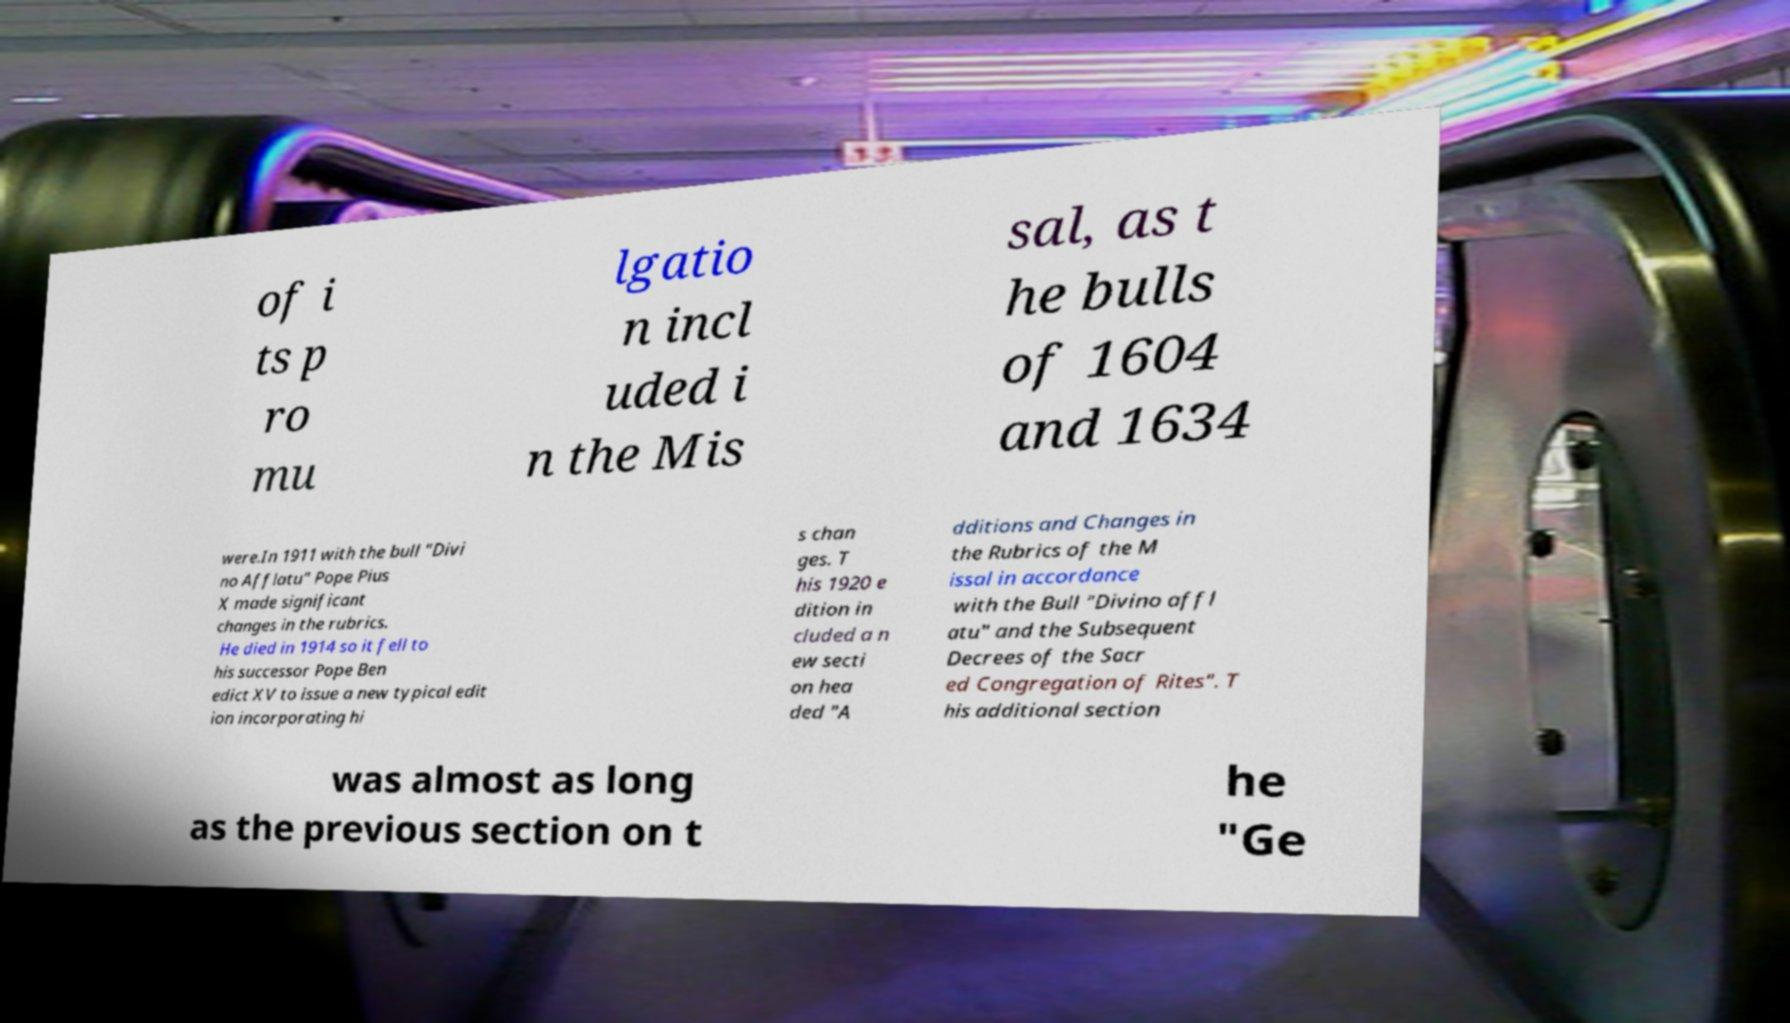I need the written content from this picture converted into text. Can you do that? of i ts p ro mu lgatio n incl uded i n the Mis sal, as t he bulls of 1604 and 1634 were.In 1911 with the bull "Divi no Afflatu" Pope Pius X made significant changes in the rubrics. He died in 1914 so it fell to his successor Pope Ben edict XV to issue a new typical edit ion incorporating hi s chan ges. T his 1920 e dition in cluded a n ew secti on hea ded "A dditions and Changes in the Rubrics of the M issal in accordance with the Bull "Divino affl atu" and the Subsequent Decrees of the Sacr ed Congregation of Rites". T his additional section was almost as long as the previous section on t he "Ge 